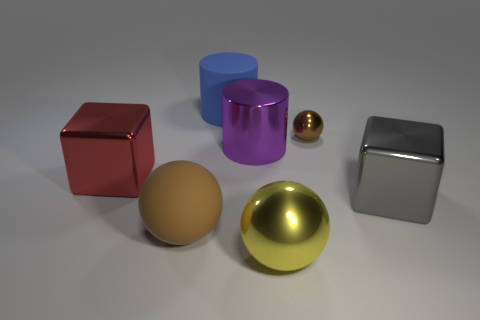Add 1 large gray things. How many objects exist? 8 Subtract all blocks. How many objects are left? 5 Add 7 small gray metallic spheres. How many small gray metallic spheres exist? 7 Subtract 0 gray spheres. How many objects are left? 7 Subtract all yellow things. Subtract all big purple cylinders. How many objects are left? 5 Add 4 red objects. How many red objects are left? 5 